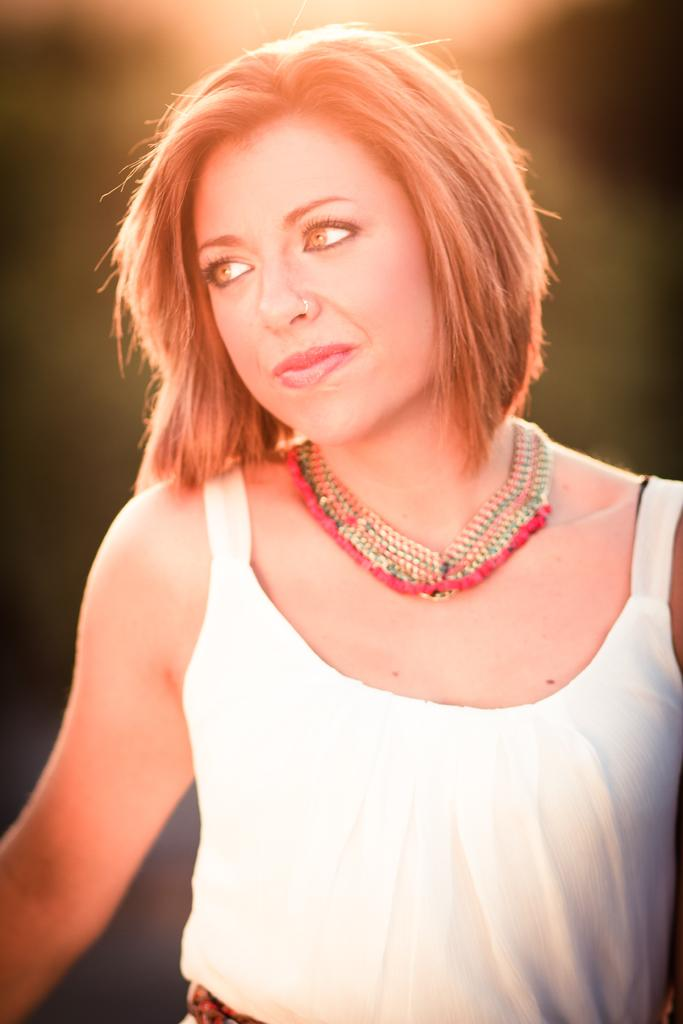What is the main subject of the picture? The main subject of the picture is a woman. What is the woman wearing around her neck? The woman is wearing a necklace. What color is the dress the woman is wearing? The woman is wearing a white dress. How would you describe the background of the image? The background of the image is blurred. Can you tell me how many gloves the woman is wearing in the image? There are no gloves visible in the image; the woman is only wearing a necklace and a white dress. What type of gun is the woman holding in the image? There is no gun present in the image; the woman is not holding any weapon. 